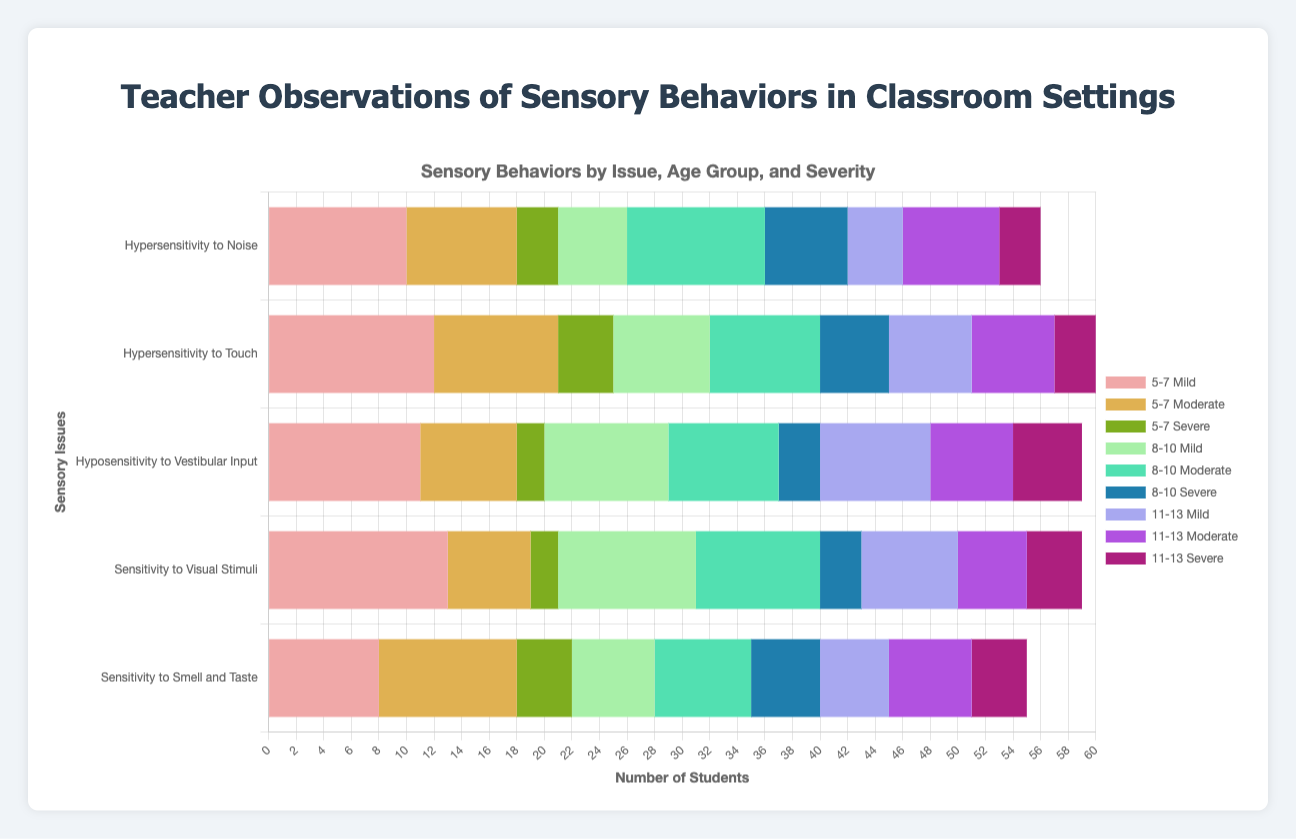Which age group has the highest number of students with Mild Hypersensitivity to Noise? Look at the "Hypersensitivity to Noise" bar across all age groups and focus on the Mild category. Compare the heights of the Mild bars for each age group. The 5-7 age group has the highest number of students with Mild Hypersensitivity to Noise.
Answer: 5-7 How many students are observed with Severe Hyposensitivity to Vestibular Input across all age groups? Sum the figures for the Severe category in Hyposensitivity to Vestibular Input across all age groups. The numbers are 2 (5-7) + 3 (8-10) + 5 (11-13), giving a total of 10.
Answer: 10 Which sensory issue in the 8-10 age group shows the highest number of Severe cases? Focus on the Severe category for the 8-10 age group and find the tallest bar. The tallest bar appears under "Hypersensitivity to Noise" and "Sensitivity to Smell and Taste," both having 6 students.
Answer: Hypersensitivity to Noise, Sensitivity to Smell and Taste What is the total number of students with Moderate Sensitivity to Visual Stimuli across all age groups? Sum the figures for the Moderate category in Sensitivity to Visual Stimuli across all age groups. These figures are 6 (5-7) + 9 (8-10) + 5 (11-13), totaling 20.
Answer: 20 Which age group shows the least number of students with Severe Hypersensitivity to Touch? Compare the Severe bars for Hypersensitivity to Touch across all age groups. The 11-13 age group has the lowest Severe cases with a count of 3.
Answer: 11-13 What is the average number of students with Mild Sensitivity to Visual Stimuli across all age groups? Sum the figures for the Mild category in Sensitivity to Visual Stimuli and divide by the number of age groups. The figures are 13 (5-7) + 10 (8-10) + 7 (11-13), totaling 30. The average is 30 / 3 = 10.
Answer: 10 